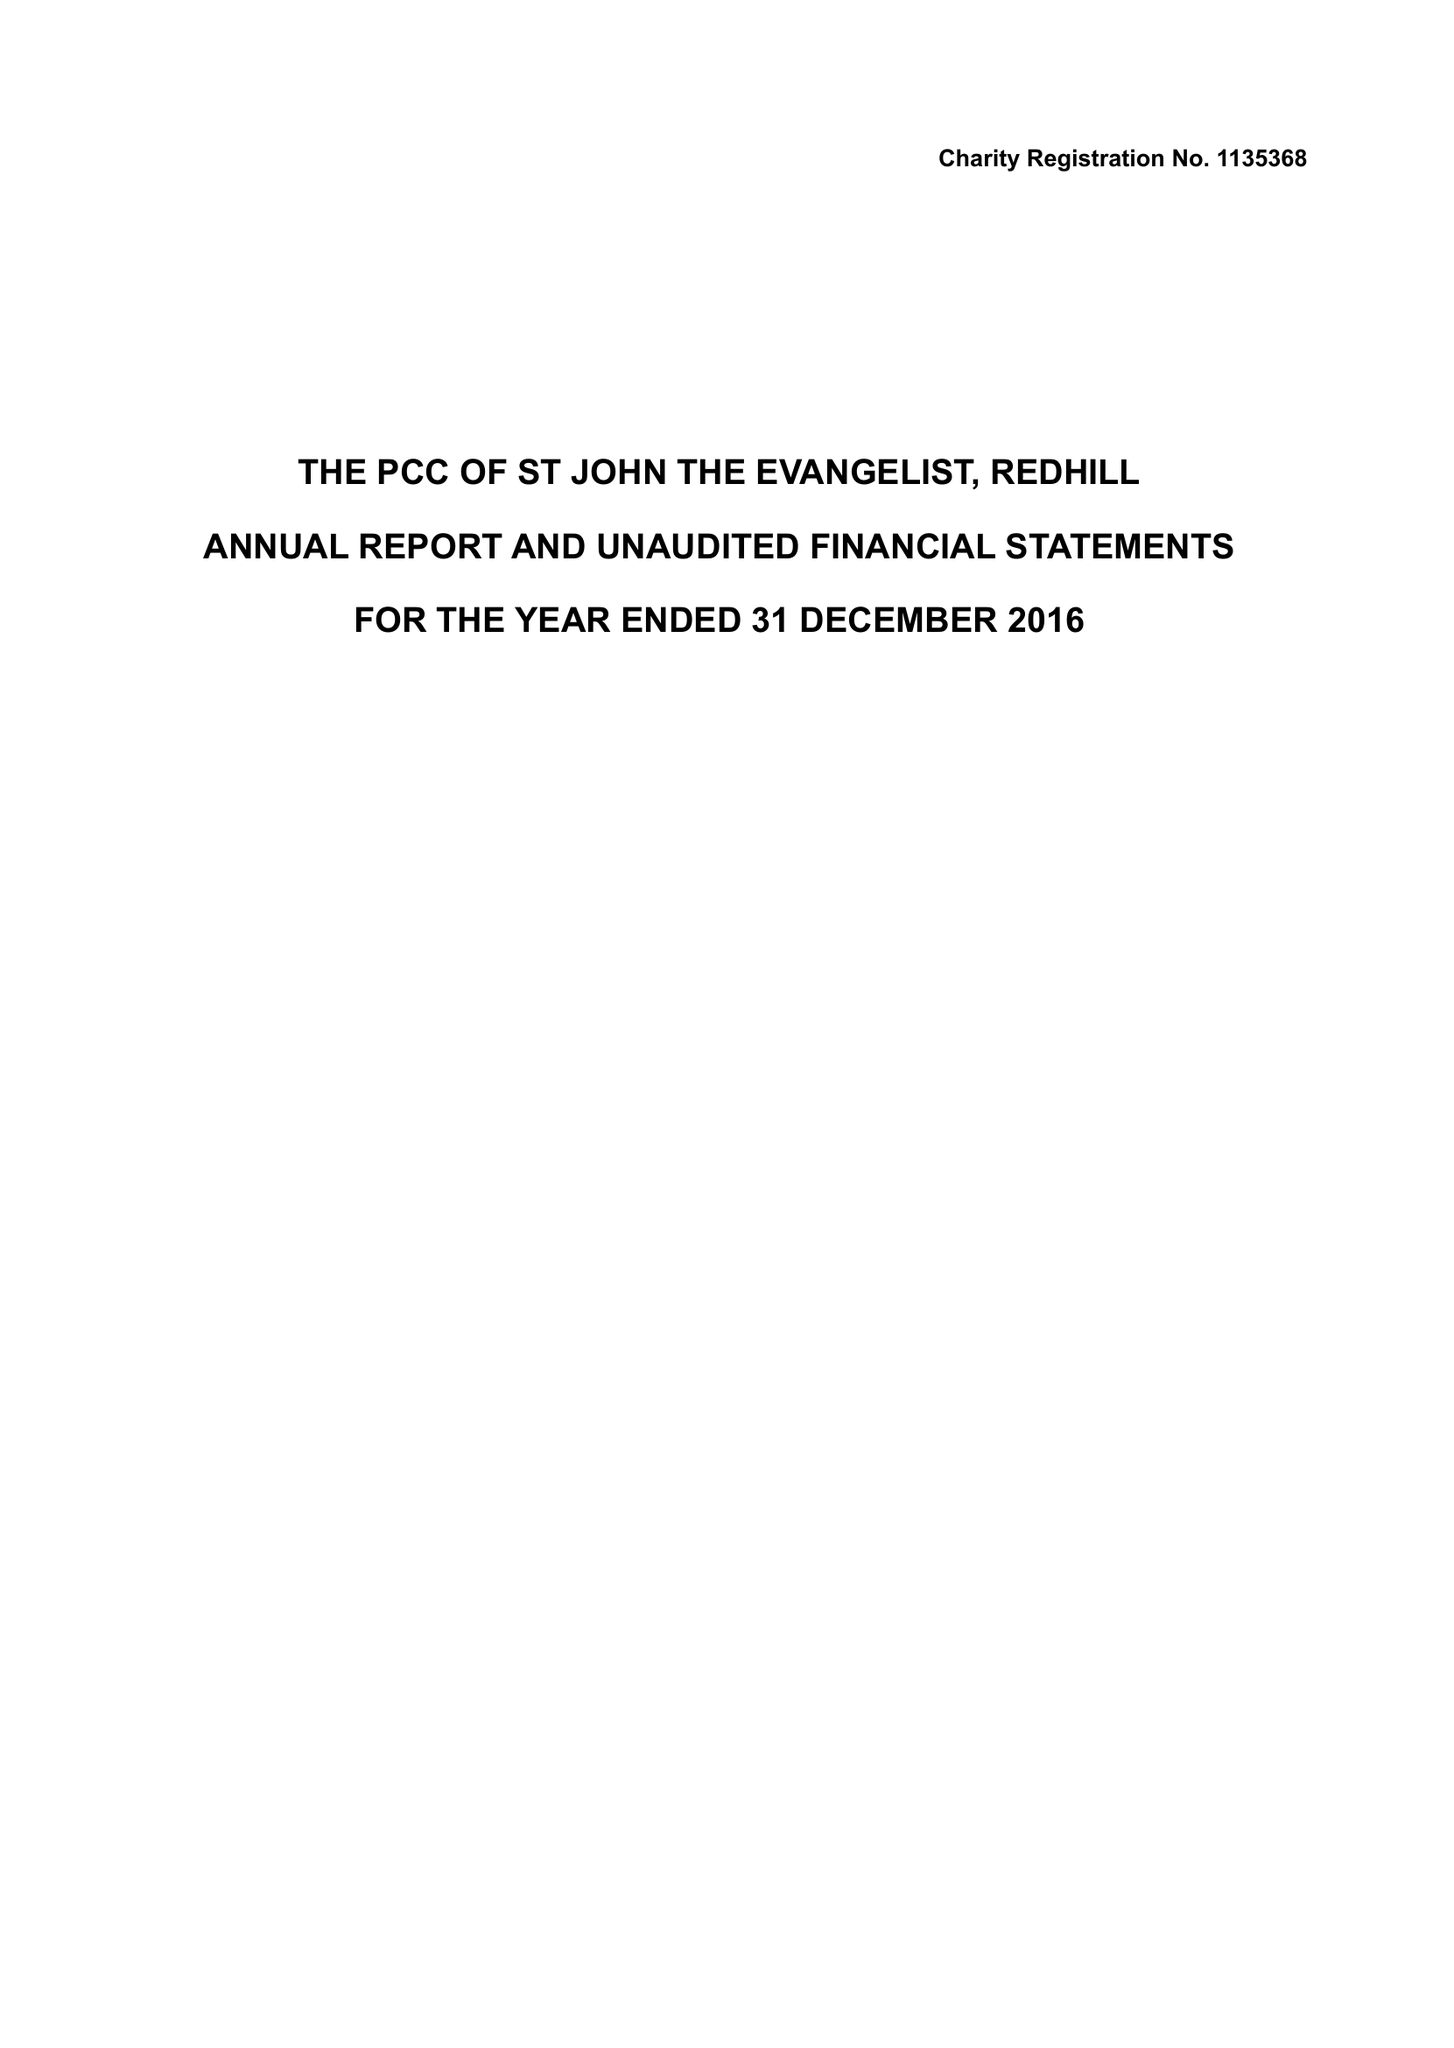What is the value for the charity_number?
Answer the question using a single word or phrase. 1135368 